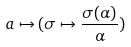Convert formula to latex. <formula><loc_0><loc_0><loc_500><loc_500>a \mapsto ( \sigma \mapsto \frac { \sigma ( \alpha ) } { \alpha } )</formula> 